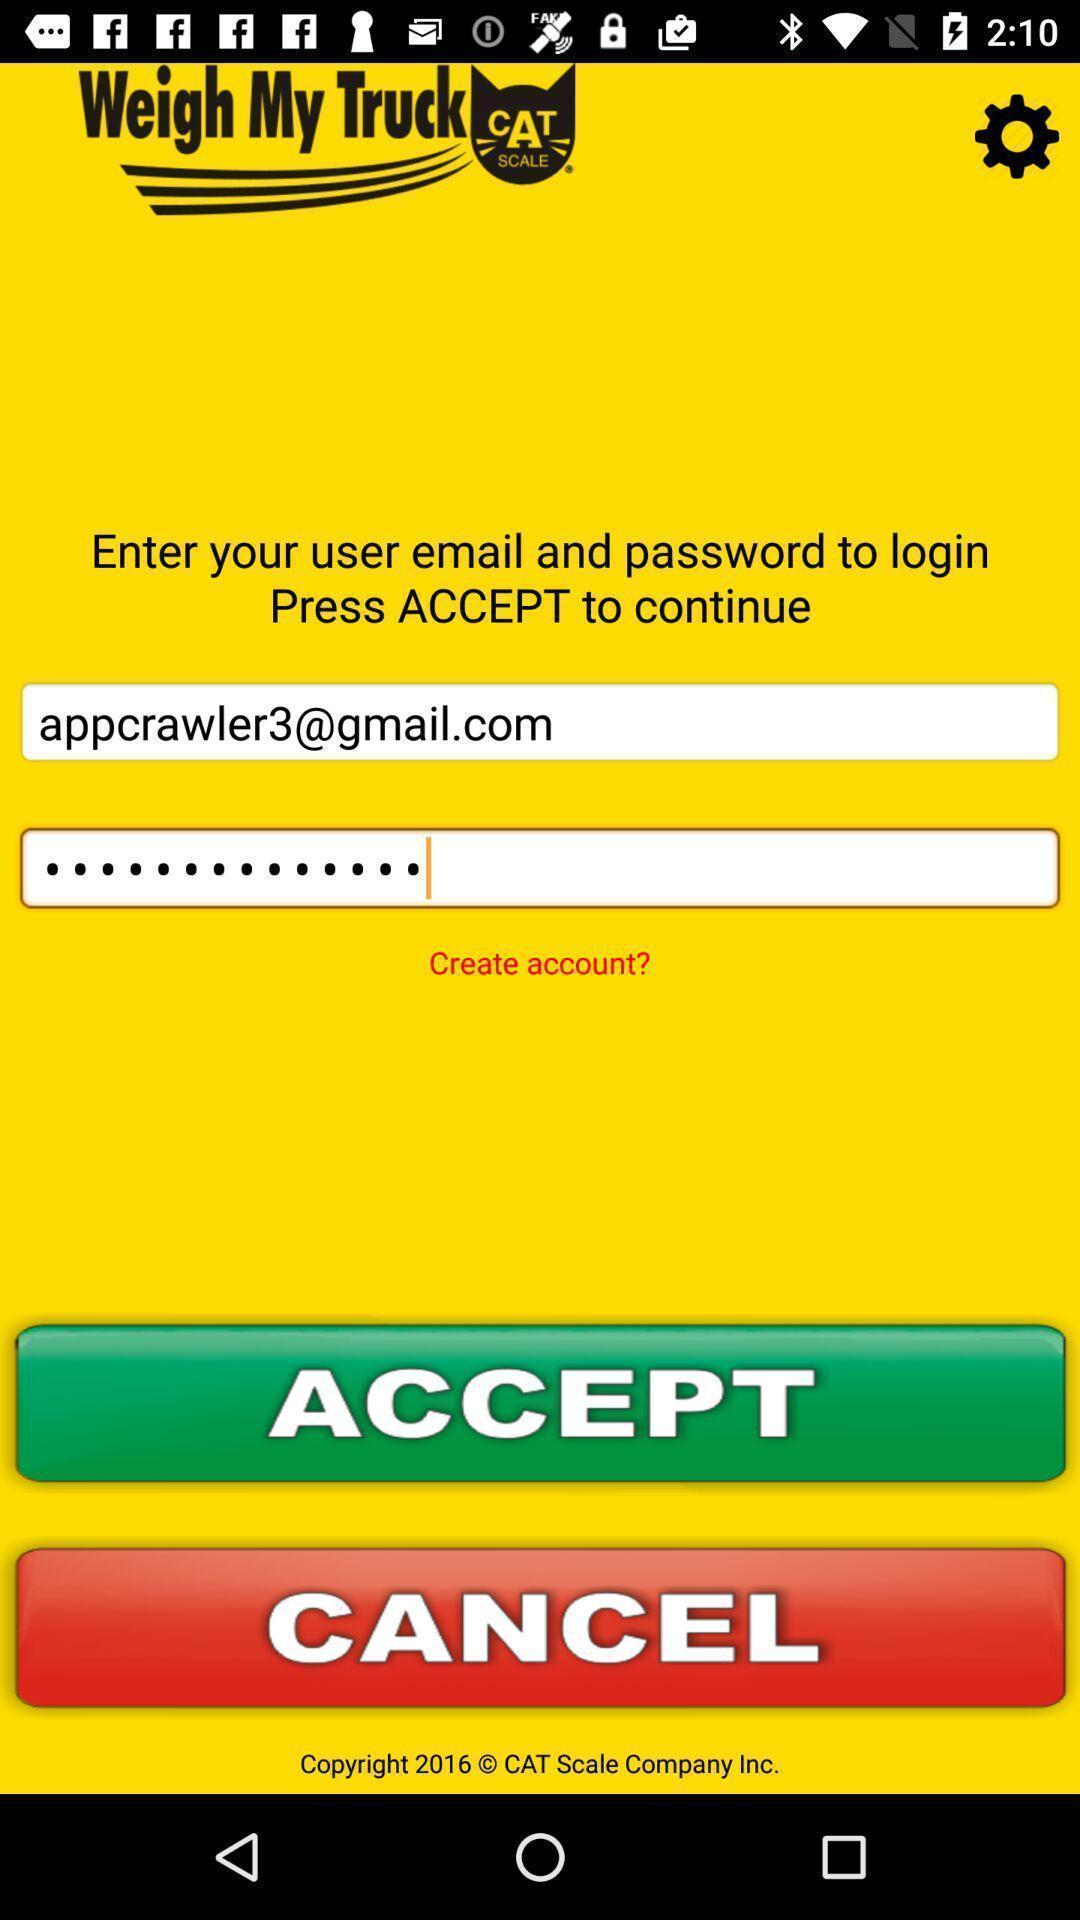Explain the elements present in this screenshot. Page showing login page. 